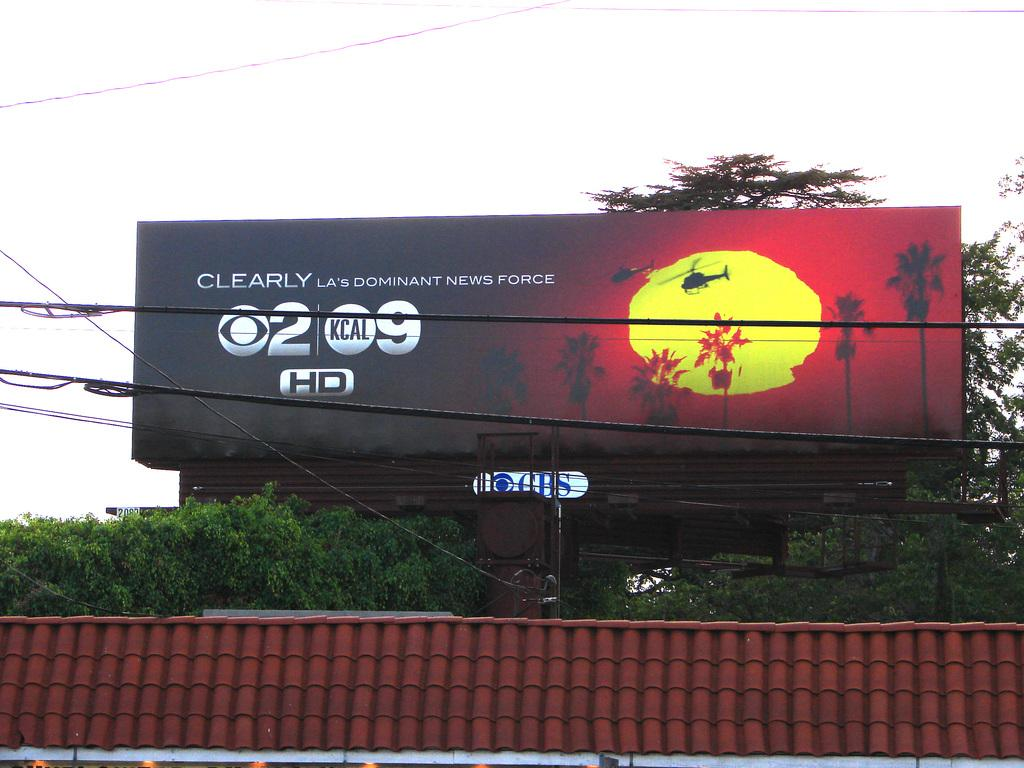Provide a one-sentence caption for the provided image. News force sign is on a banner outside on top of a building. 